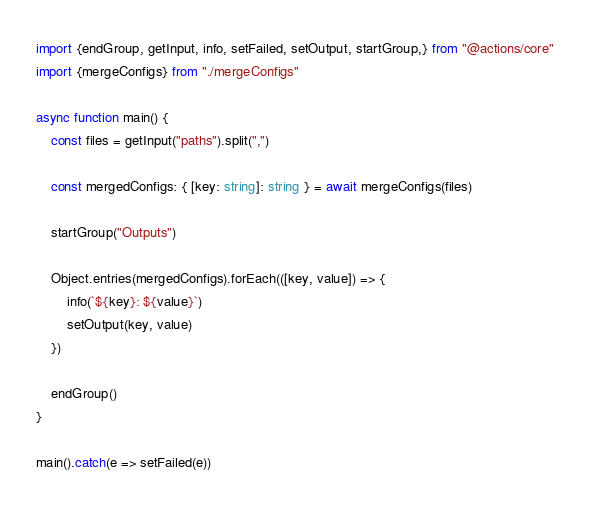Convert code to text. <code><loc_0><loc_0><loc_500><loc_500><_TypeScript_>import {endGroup, getInput, info, setFailed, setOutput, startGroup,} from "@actions/core"
import {mergeConfigs} from "./mergeConfigs"

async function main() {
    const files = getInput("paths").split(",")

    const mergedConfigs: { [key: string]: string } = await mergeConfigs(files)

    startGroup("Outputs")

    Object.entries(mergedConfigs).forEach(([key, value]) => {
        info(`${key}: ${value}`)
        setOutput(key, value)
    })

    endGroup()
}

main().catch(e => setFailed(e))
</code> 